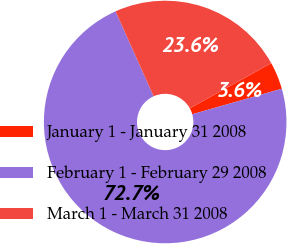Convert chart. <chart><loc_0><loc_0><loc_500><loc_500><pie_chart><fcel>January 1 - January 31 2008<fcel>February 1 - February 29 2008<fcel>March 1 - March 31 2008<nl><fcel>3.64%<fcel>72.72%<fcel>23.65%<nl></chart> 